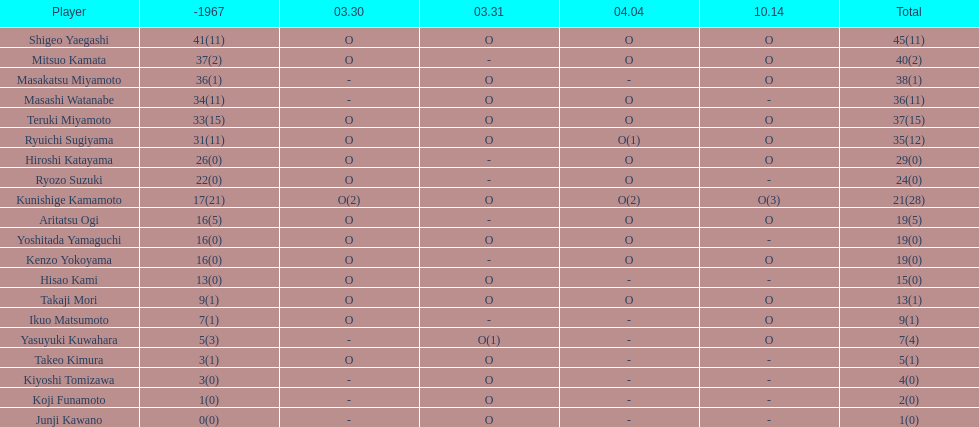Can you provide the sum of all appearances by masakatsu miyamoto? 38. 